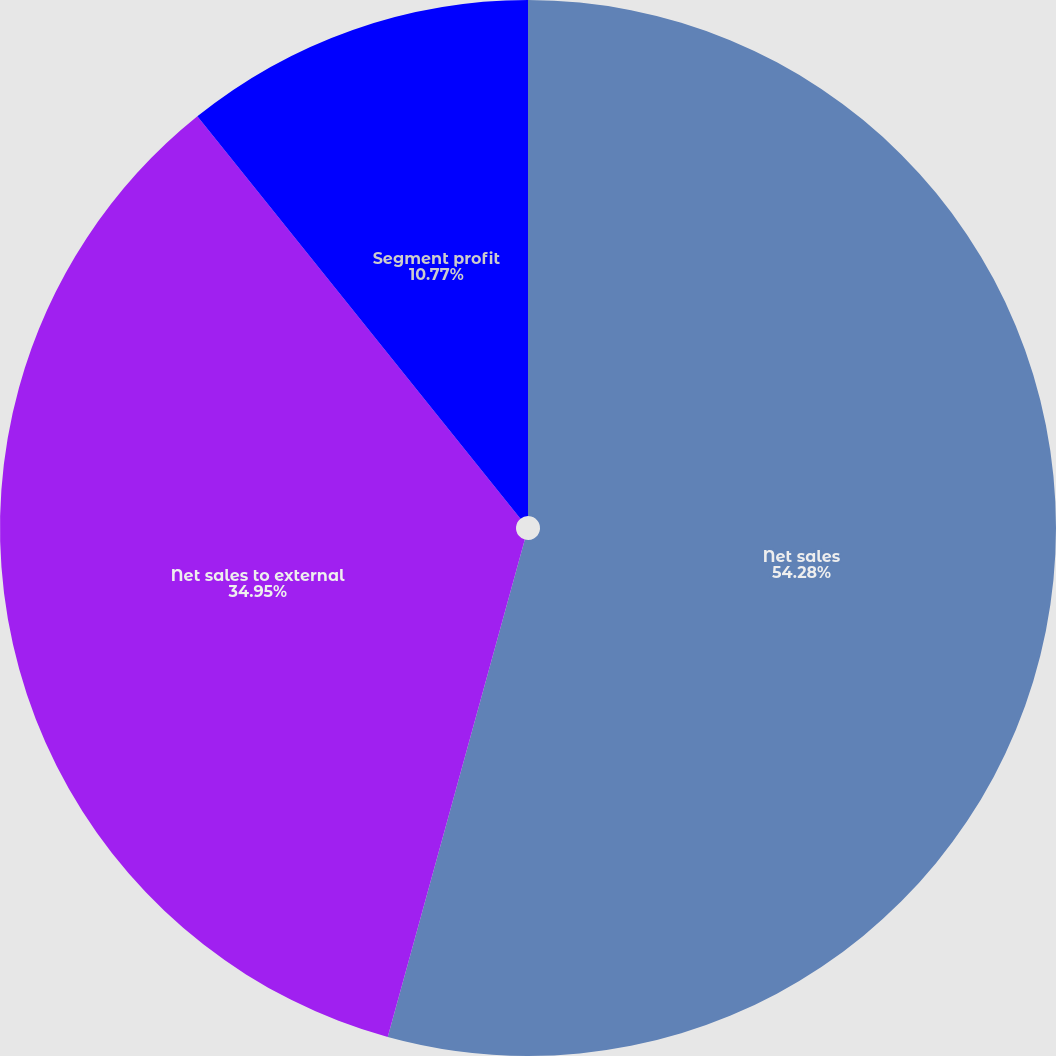<chart> <loc_0><loc_0><loc_500><loc_500><pie_chart><fcel>Net sales<fcel>Net sales to external<fcel>Segment profit<nl><fcel>54.28%<fcel>34.95%<fcel>10.77%<nl></chart> 